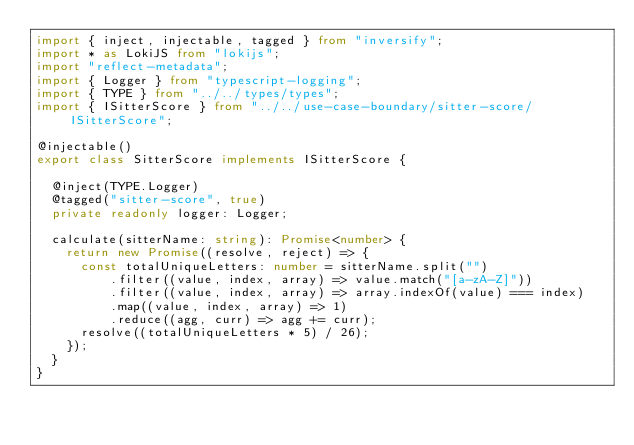<code> <loc_0><loc_0><loc_500><loc_500><_TypeScript_>import { inject, injectable, tagged } from "inversify";
import * as LokiJS from "lokijs";
import "reflect-metadata";
import { Logger } from "typescript-logging";
import { TYPE } from "../../types/types";
import { ISitterScore } from "../../use-case-boundary/sitter-score/ISitterScore";

@injectable()
export class SitterScore implements ISitterScore {

  @inject(TYPE.Logger)
  @tagged("sitter-score", true)
  private readonly logger: Logger;

  calculate(sitterName: string): Promise<number> {
    return new Promise((resolve, reject) => {
      const totalUniqueLetters: number = sitterName.split("")
          .filter((value, index, array) => value.match("[a-zA-Z]"))
          .filter((value, index, array) => array.indexOf(value) === index)
          .map((value, index, array) => 1)
          .reduce((agg, curr) => agg += curr);
      resolve((totalUniqueLetters * 5) / 26);
    });
  }
}
</code> 